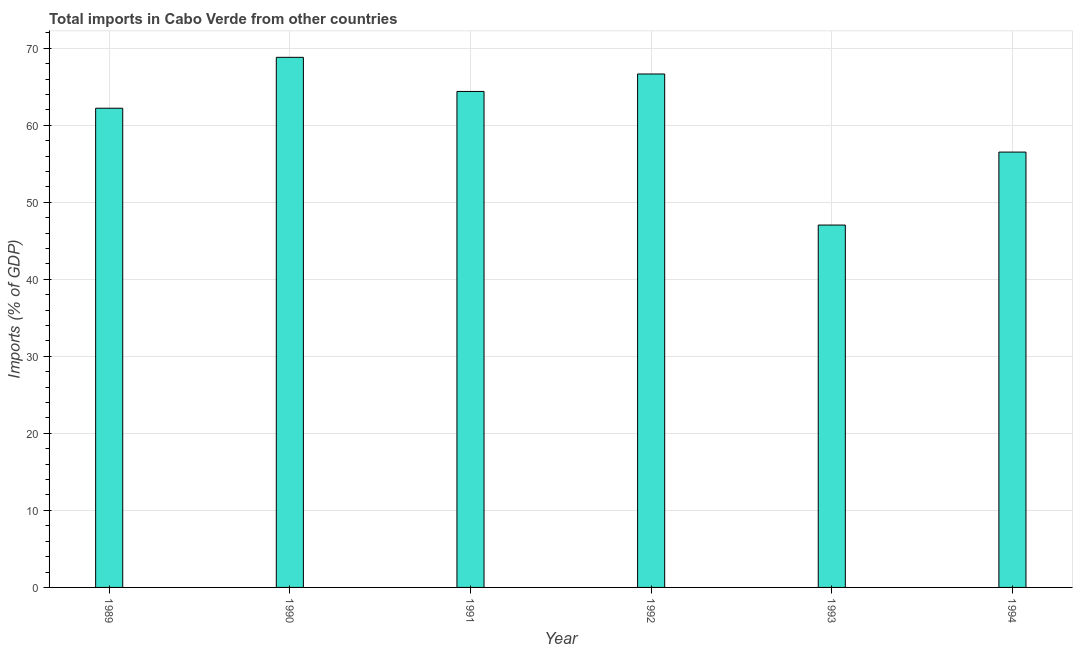Does the graph contain any zero values?
Offer a terse response. No. Does the graph contain grids?
Provide a succinct answer. Yes. What is the title of the graph?
Your response must be concise. Total imports in Cabo Verde from other countries. What is the label or title of the X-axis?
Provide a succinct answer. Year. What is the label or title of the Y-axis?
Offer a very short reply. Imports (% of GDP). What is the total imports in 1993?
Ensure brevity in your answer.  47.05. Across all years, what is the maximum total imports?
Give a very brief answer. 68.82. Across all years, what is the minimum total imports?
Ensure brevity in your answer.  47.05. In which year was the total imports minimum?
Your answer should be compact. 1993. What is the sum of the total imports?
Give a very brief answer. 365.64. What is the difference between the total imports in 1989 and 1993?
Your answer should be compact. 15.17. What is the average total imports per year?
Ensure brevity in your answer.  60.94. What is the median total imports?
Make the answer very short. 63.3. What is the ratio of the total imports in 1992 to that in 1994?
Offer a very short reply. 1.18. Is the total imports in 1990 less than that in 1991?
Provide a succinct answer. No. Is the difference between the total imports in 1990 and 1993 greater than the difference between any two years?
Keep it short and to the point. Yes. What is the difference between the highest and the second highest total imports?
Provide a short and direct response. 2.16. Is the sum of the total imports in 1990 and 1991 greater than the maximum total imports across all years?
Offer a very short reply. Yes. What is the difference between the highest and the lowest total imports?
Offer a terse response. 21.77. Are the values on the major ticks of Y-axis written in scientific E-notation?
Give a very brief answer. No. What is the Imports (% of GDP) of 1989?
Keep it short and to the point. 62.21. What is the Imports (% of GDP) in 1990?
Your answer should be compact. 68.82. What is the Imports (% of GDP) of 1991?
Give a very brief answer. 64.39. What is the Imports (% of GDP) in 1992?
Ensure brevity in your answer.  66.66. What is the Imports (% of GDP) of 1993?
Your answer should be very brief. 47.05. What is the Imports (% of GDP) in 1994?
Your answer should be compact. 56.52. What is the difference between the Imports (% of GDP) in 1989 and 1990?
Your response must be concise. -6.61. What is the difference between the Imports (% of GDP) in 1989 and 1991?
Your answer should be very brief. -2.18. What is the difference between the Imports (% of GDP) in 1989 and 1992?
Provide a short and direct response. -4.44. What is the difference between the Imports (% of GDP) in 1989 and 1993?
Give a very brief answer. 15.17. What is the difference between the Imports (% of GDP) in 1989 and 1994?
Ensure brevity in your answer.  5.7. What is the difference between the Imports (% of GDP) in 1990 and 1991?
Make the answer very short. 4.43. What is the difference between the Imports (% of GDP) in 1990 and 1992?
Give a very brief answer. 2.16. What is the difference between the Imports (% of GDP) in 1990 and 1993?
Make the answer very short. 21.77. What is the difference between the Imports (% of GDP) in 1990 and 1994?
Provide a short and direct response. 12.3. What is the difference between the Imports (% of GDP) in 1991 and 1992?
Ensure brevity in your answer.  -2.27. What is the difference between the Imports (% of GDP) in 1991 and 1993?
Give a very brief answer. 17.34. What is the difference between the Imports (% of GDP) in 1991 and 1994?
Provide a succinct answer. 7.87. What is the difference between the Imports (% of GDP) in 1992 and 1993?
Offer a terse response. 19.61. What is the difference between the Imports (% of GDP) in 1992 and 1994?
Your answer should be very brief. 10.14. What is the difference between the Imports (% of GDP) in 1993 and 1994?
Your response must be concise. -9.47. What is the ratio of the Imports (% of GDP) in 1989 to that in 1990?
Ensure brevity in your answer.  0.9. What is the ratio of the Imports (% of GDP) in 1989 to that in 1991?
Make the answer very short. 0.97. What is the ratio of the Imports (% of GDP) in 1989 to that in 1992?
Provide a succinct answer. 0.93. What is the ratio of the Imports (% of GDP) in 1989 to that in 1993?
Make the answer very short. 1.32. What is the ratio of the Imports (% of GDP) in 1989 to that in 1994?
Give a very brief answer. 1.1. What is the ratio of the Imports (% of GDP) in 1990 to that in 1991?
Offer a terse response. 1.07. What is the ratio of the Imports (% of GDP) in 1990 to that in 1992?
Provide a short and direct response. 1.03. What is the ratio of the Imports (% of GDP) in 1990 to that in 1993?
Ensure brevity in your answer.  1.46. What is the ratio of the Imports (% of GDP) in 1990 to that in 1994?
Provide a short and direct response. 1.22. What is the ratio of the Imports (% of GDP) in 1991 to that in 1993?
Your answer should be compact. 1.37. What is the ratio of the Imports (% of GDP) in 1991 to that in 1994?
Keep it short and to the point. 1.14. What is the ratio of the Imports (% of GDP) in 1992 to that in 1993?
Offer a terse response. 1.42. What is the ratio of the Imports (% of GDP) in 1992 to that in 1994?
Offer a terse response. 1.18. What is the ratio of the Imports (% of GDP) in 1993 to that in 1994?
Ensure brevity in your answer.  0.83. 